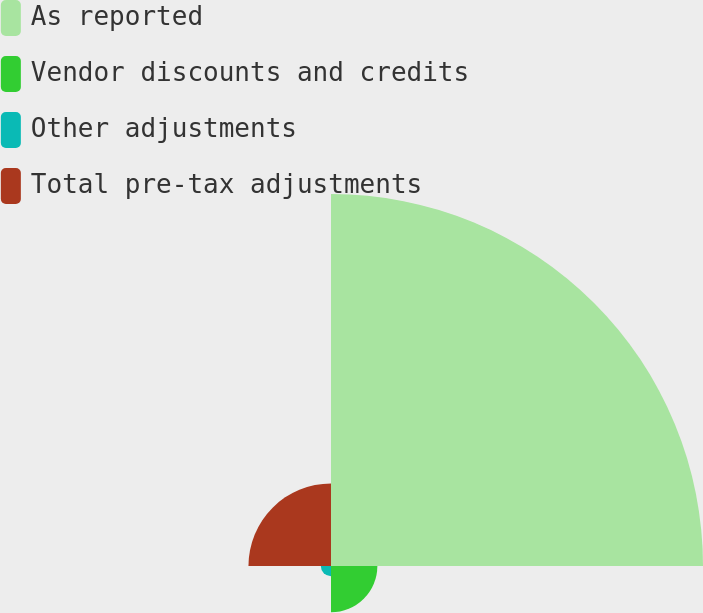Convert chart to OTSL. <chart><loc_0><loc_0><loc_500><loc_500><pie_chart><fcel>As reported<fcel>Vendor discounts and credits<fcel>Other adjustments<fcel>Total pre-tax adjustments<nl><fcel>72.79%<fcel>9.07%<fcel>1.99%<fcel>16.15%<nl></chart> 